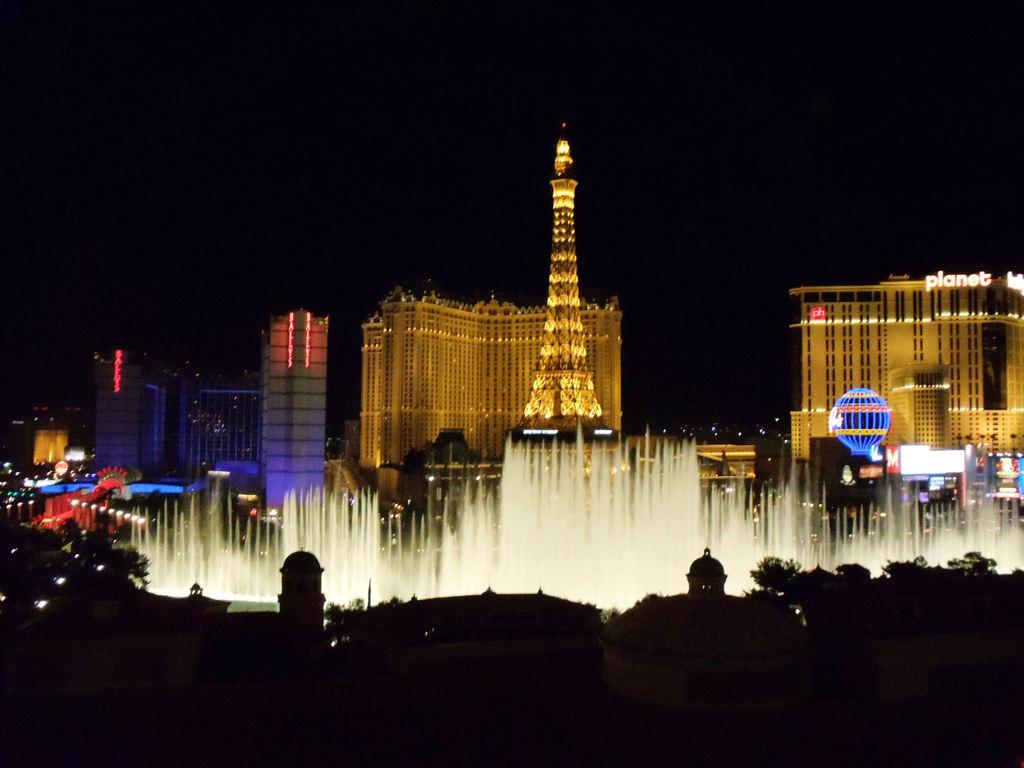What type of structures are present in the image? There are buildings in the image. What colors are the buildings? The buildings are in brown and white color. What can be seen illuminated in the image? There are lights visible in the image. How would you describe the overall lighting in the image? The background of the image is dark. What time of day is it in the image, given that it is morning? The provided facts do not mention the time of day, and there is no indication of morning in the image. 